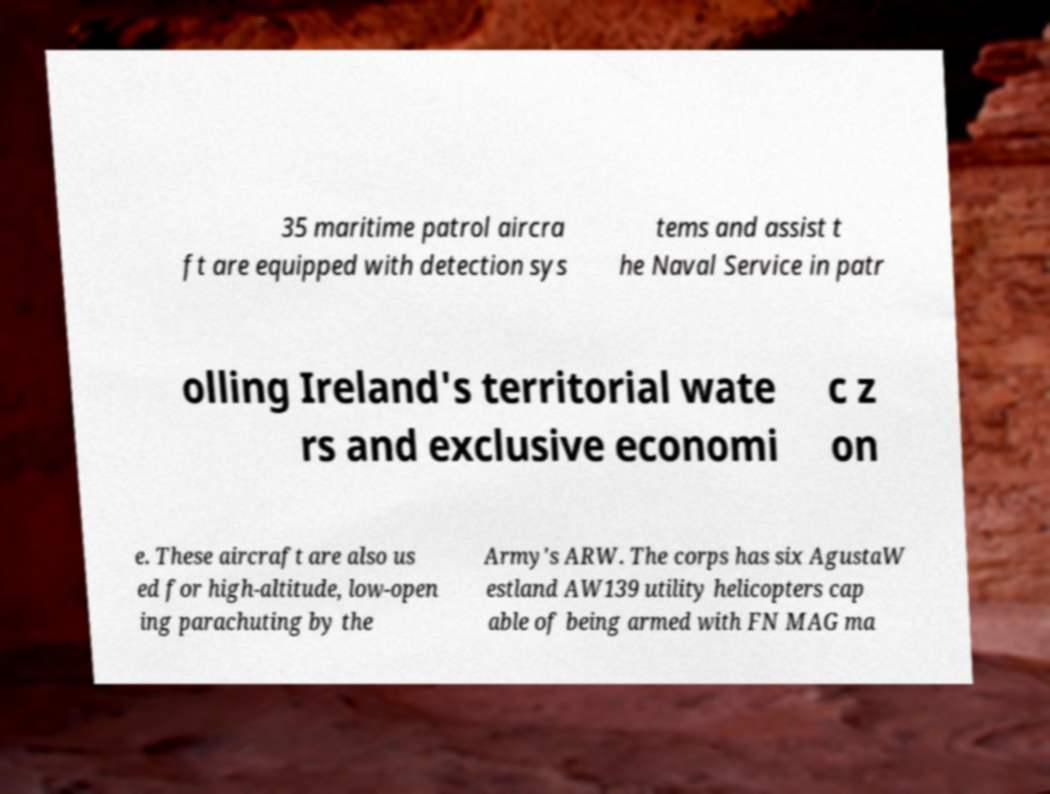What messages or text are displayed in this image? I need them in a readable, typed format. 35 maritime patrol aircra ft are equipped with detection sys tems and assist t he Naval Service in patr olling Ireland's territorial wate rs and exclusive economi c z on e. These aircraft are also us ed for high-altitude, low-open ing parachuting by the Army's ARW. The corps has six AgustaW estland AW139 utility helicopters cap able of being armed with FN MAG ma 